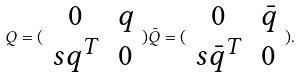<formula> <loc_0><loc_0><loc_500><loc_500>Q = ( \begin{array} { c c } 0 & q \\ s q ^ { T } & 0 \end{array} ) \bar { Q } = ( \begin{array} { c c } 0 & \bar { q } \\ s \bar { q } ^ { T } & 0 \end{array} ) .</formula> 